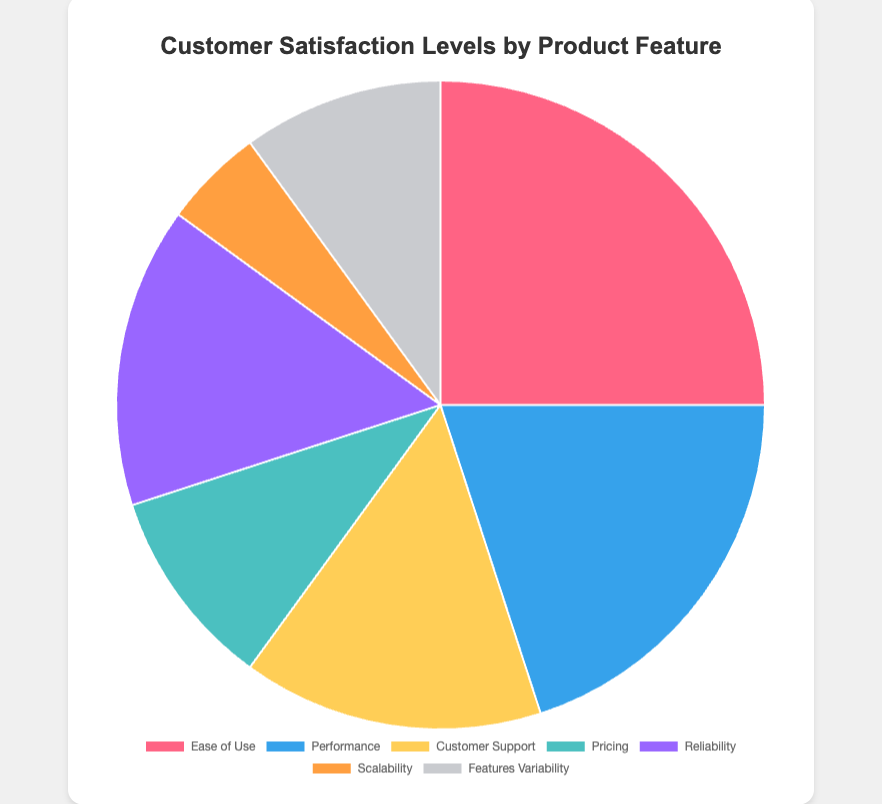Which product feature has the highest customer satisfaction level? The figure shows the distribution of customer satisfaction levels by product feature. The "Ease of Use" slice is the largest, indicating it has the highest satisfaction level.
Answer: Ease of Use Which product feature has the lowest customer satisfaction level? The figure displays different satisfaction levels encoded in pie slice sizes. The smallest slice corresponds to "Scalability," indicating it has the lowest satisfaction level.
Answer: Scalability How do the satisfaction levels of "Reliability" and "Customer Support" compare? The figure differentiates features by slice size. Both "Reliability" and "Customer Support" have similarly sized slices, indicating they have equal satisfaction levels (15%).
Answer: Equal What is the combined satisfaction level for "Pricing" and "Features Variability"? From the figure, "Pricing" is 10% and "Features Variability" is also 10%. Adding these two percentages gives: 10% + 10% = 20%.
Answer: 20% Which two product features combined account for half (50%) of the total customer satisfaction? The figure's slice sizes show "Ease of Use" is 25% and "Performance" is 20%. Adding these, 25% + 20% = 45%. Including "Customer Support" (15%) would exceed 50%. So, "Ease of Use" and "Performance" combined contribute the closest to half.
Answer: Ease of Use and Performance What is the difference in satisfaction levels between "Ease of Use" and "Performance"? Referring to the figure, "Ease of Use" is 25% while "Performance" is 20%. The difference is calculated as: 25% - 20% = 5%.
Answer: 5% How does the satisfaction level of "Scalability" compare to the average satisfaction level of all product features? To find the average satisfaction level, sum all percentages: 25% + 20% + 15% + 10% + 15% + 5% + 10% = 100%. There are 7 features, so the average is 100%/7 = ~14.3%. "Scalability" is 5%, which is below the average.
Answer: Below average Out of "Pricing," "Scalability," and "Features Variability," which has the highest satisfaction level? The figure displays "Pricing" and "Features Variability" each at 10%, while "Scalability" is at 5%. Therefore, "Pricing" and "Features Variability" have the highest and equal satisfaction levels among the three.
Answer: Pricing and Features Variability How much higher is the satisfaction level for "Ease of Use" compared to "Scalability"? From the figure, "Ease of Use" is at 25%, and "Scalability" is at 5%. The difference is: 25% - 5% = 20%.
Answer: 20% What is the total satisfaction level for all product features except "Ease of Use"? The total satisfaction level for all features is 100%. Subtracting "Ease of Use" (25%): 100% - 25% = 75%.
Answer: 75% 